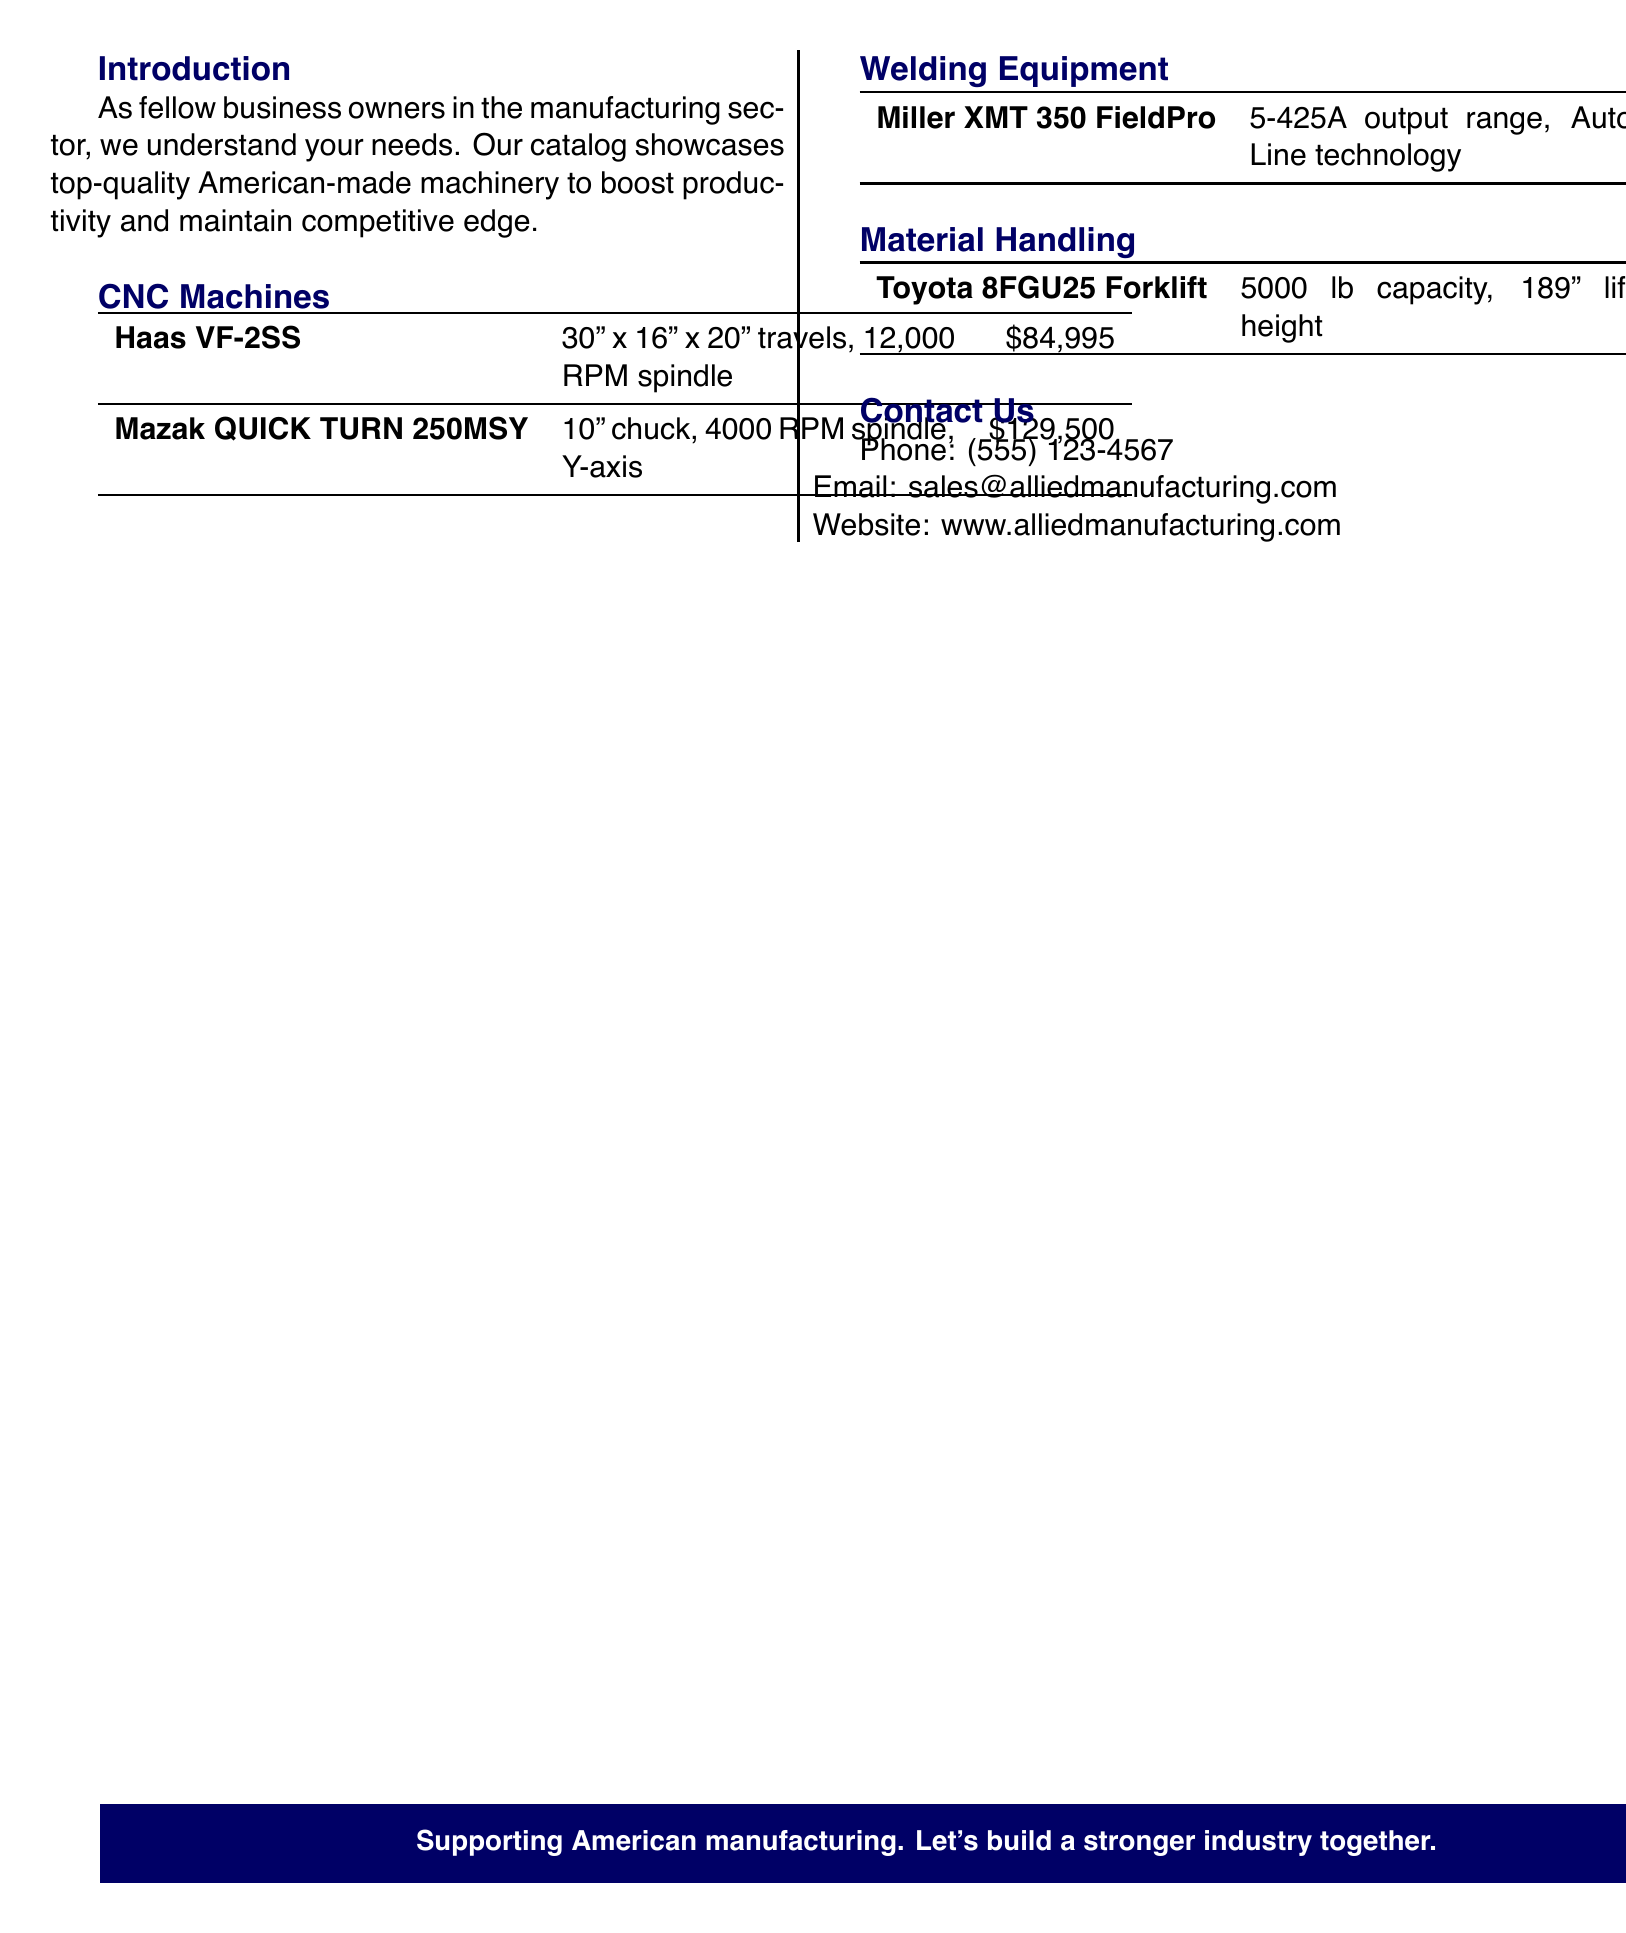What is the title of the document? The title of the document is found at the top of the catalog.
Answer: Premium Industrial Machinery & Equipment Which company is presenting the catalog? The name of the company can be found in the header of the catalog.
Answer: Allied Manufacturing Solutions What is the travel distance of the Haas VF-2SS? The travel distance is specified in the CNC Machines section of the catalog.
Answer: 30" x 16" x 20" How much does the Mazak QUICK TURN 250MSY cost? The cost of the Mazak QUICK TURN 250MSY is included in the specifications table of CNC Machines.
Answer: $129,500 What is the output range of the Miller XMT 350 FieldPro? This information is provided in the Welding Equipment section of the catalog.
Answer: 5-425A What is the lift height of the Toyota 8FGU25 Forklift? The lift height is mentioned under Material Handling specifications.
Answer: 189" What is the contact phone number for Allied Manufacturing Solutions? The contact information is located at the end of the catalog.
Answer: (555) 123-4567 What type of equipment is listed under Material Handling? The type of equipment can be identified in the respective section of the catalog.
Answer: Forklift What key feature does the Miller XMT 350 FieldPro include? Key features of the welding equipment are outlined in the document.
Answer: Auto-Line technology 